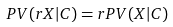Convert formula to latex. <formula><loc_0><loc_0><loc_500><loc_500>P V ( r X | C ) = r P V ( X | C )</formula> 